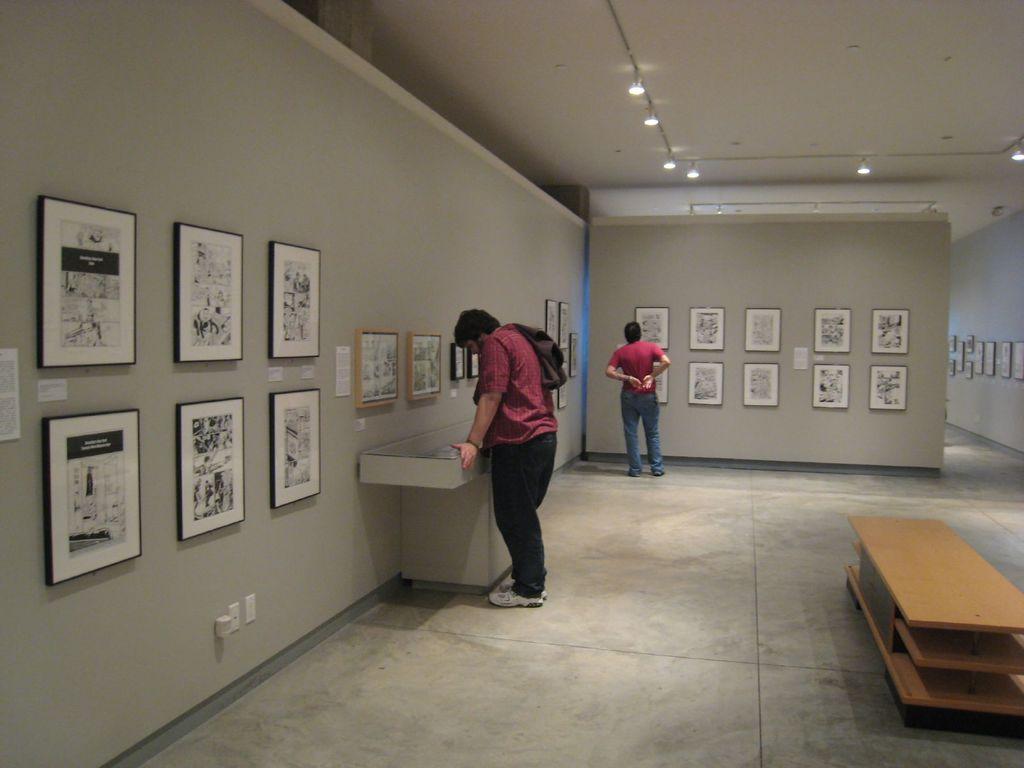Can you describe this image briefly? It looks like an art gallery there are a lot of pictures and photo frames on the wall, two people are spectating at the pictures ,the wall is of grey color there is also a table in middle of the room. 